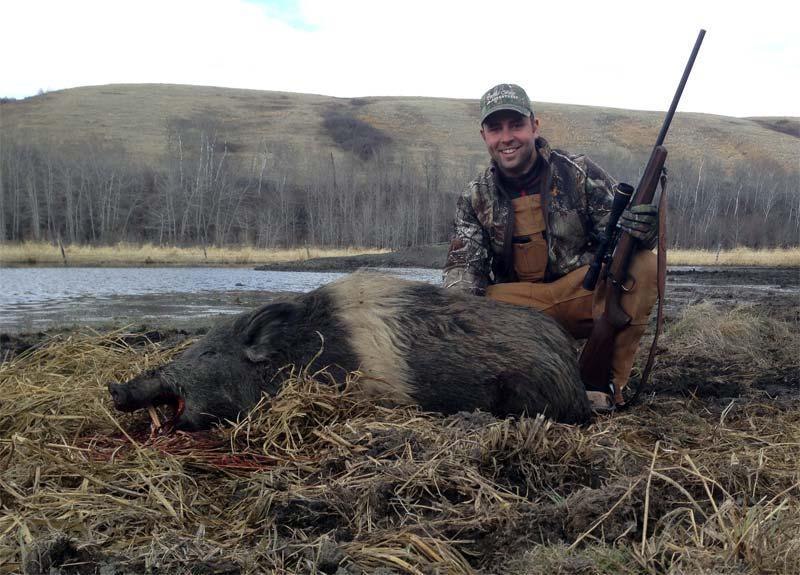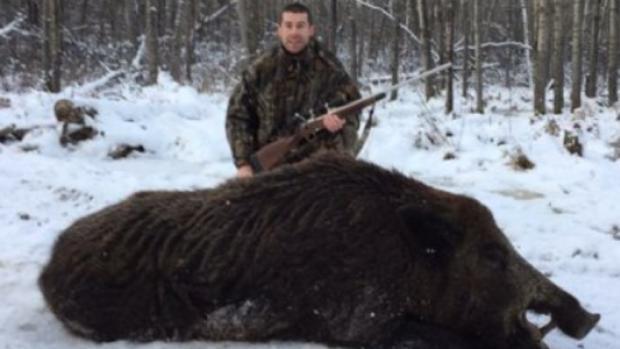The first image is the image on the left, the second image is the image on the right. Assess this claim about the two images: "One of the images has at least one person posing over a dead animal on snowy ground.". Correct or not? Answer yes or no. Yes. The first image is the image on the left, the second image is the image on the right. Evaluate the accuracy of this statement regarding the images: "A man is holding a gun horizontally.". Is it true? Answer yes or no. Yes. 